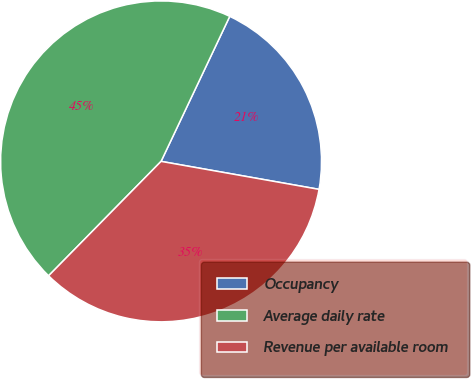Convert chart. <chart><loc_0><loc_0><loc_500><loc_500><pie_chart><fcel>Occupancy<fcel>Average daily rate<fcel>Revenue per available room<nl><fcel>20.75%<fcel>44.67%<fcel>34.57%<nl></chart> 